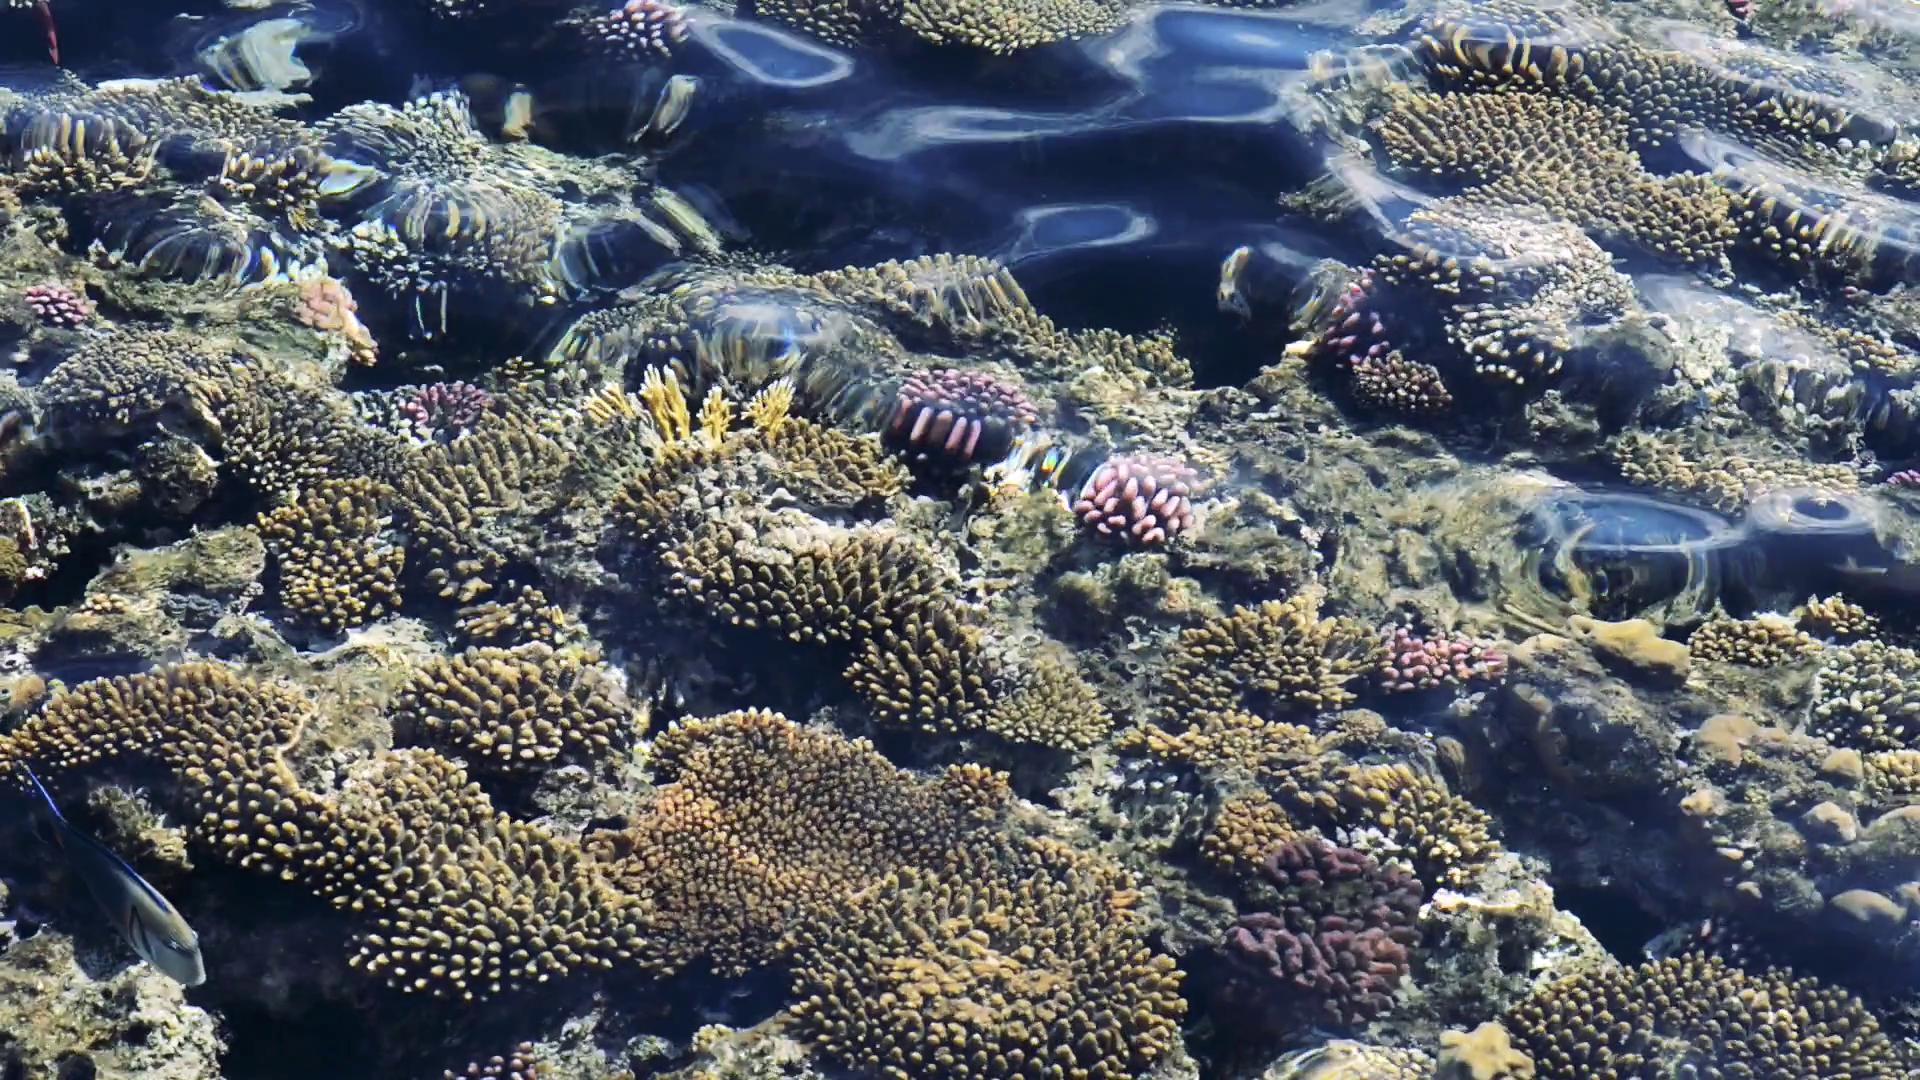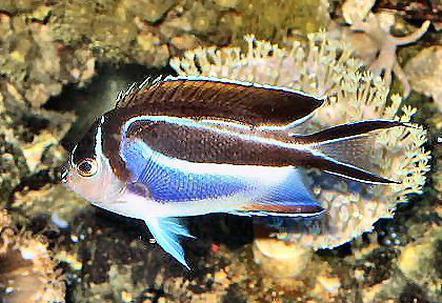The first image is the image on the left, the second image is the image on the right. Evaluate the accuracy of this statement regarding the images: "The right image shows a single prominent fish displayed in profile with some blue coloring, and the left image shows beds of coral or anemone with no fish present and with touches of violet color.". Is it true? Answer yes or no. Yes. The first image is the image on the left, the second image is the image on the right. Evaluate the accuracy of this statement regarding the images: "Some fish are facing toward the right.". Is it true? Answer yes or no. No. 